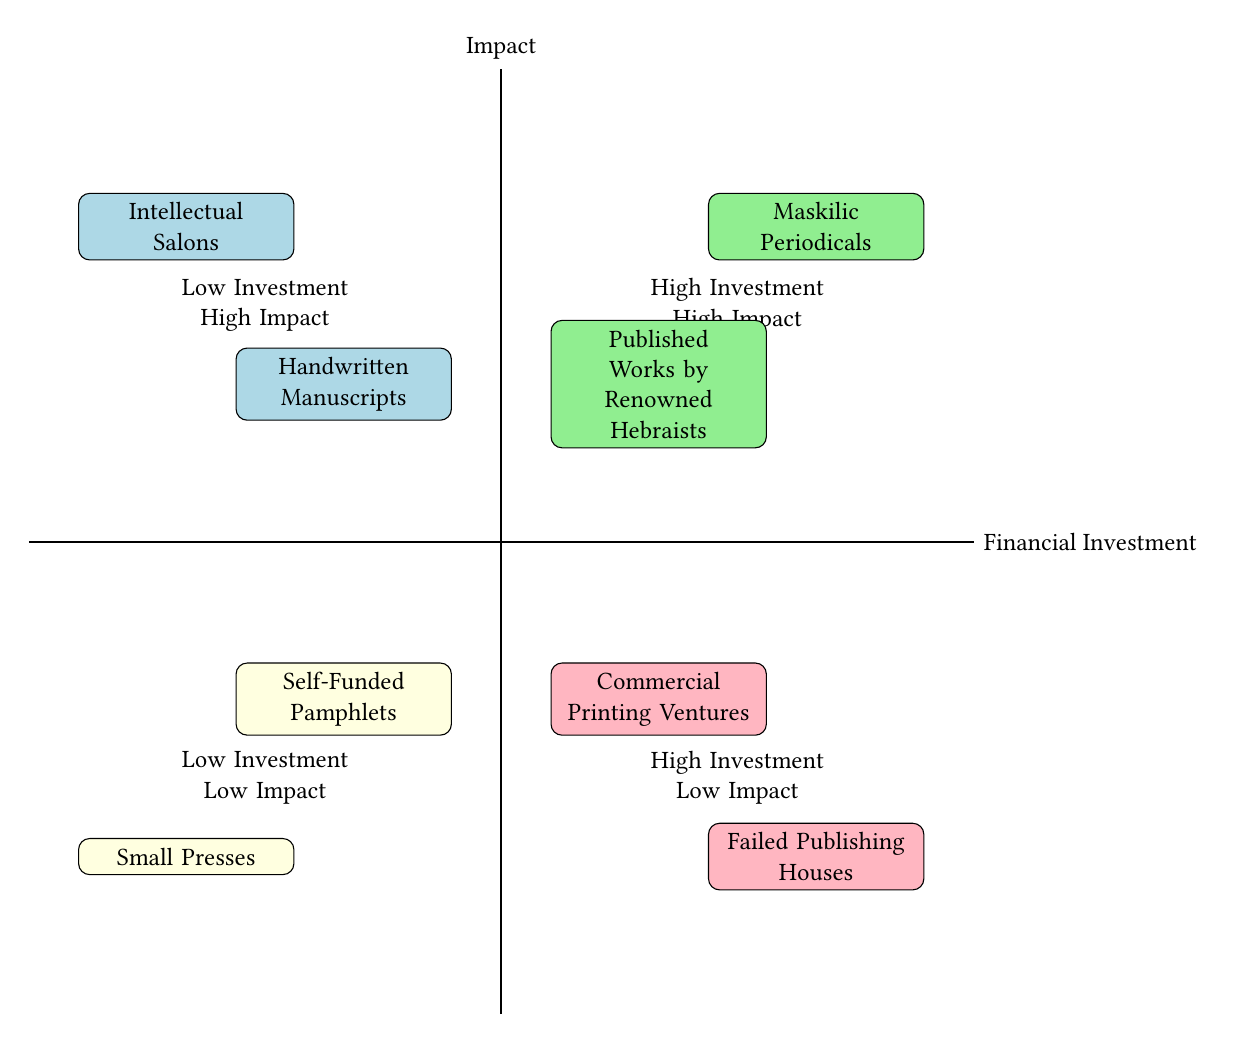What's in the Low Investment High Impact quadrant? The Low Investment High Impact quadrant contains "Intellectual Salons" and "Handwritten Manuscripts." By locating this quadrant on the chart, we can identify these two specific nodes that signify low financial investment but high cultural or literary impact.
Answer: Intellectual Salons, Handwritten Manuscripts What is a characteristic of "Maskilic Periodicals"? "Maskilic Periodicals" is highlighted in the High Investment High Impact quadrant, indicating it has significant funding while also achieving widespread distribution and lasting influence. This specific node's placement signifies its high financial investment and high impact on Hebrew literature.
Answer: Significant funding, wide distribution, lasting influence How many nodes are in the Low Financial Investment Low Impact quadrant? The Low Financial Investment Low Impact quadrant includes two nodes: "Small Presses" and "Self-Funded Pamphlets." By counting the nodes located in this quadrant, we can determine the total number present.
Answer: 2 Which quadrant has "Failed Publishing Houses"? "Failed Publishing Houses" is located in the High Investment Low Impact quadrant. By looking for this specific node on the diagram, it becomes clear where it fits in terms of financial investment and impact.
Answer: High Investment Low Impact Which two categories demonstrate high financial investment along with impactful contributions? The High Investment High Impact quadrant features "Maskilic Periodicals" and "Published Works by Renowned Hebraists." By identifying these nodes together in this quadrant, we can see they both represent high costs and significant influence in Hebrew literary works.
Answer: Maskilic Periodicals, Published Works by Renowned Hebraists What can be inferred about "Handwritten Manuscripts"? "Handwritten Manuscripts," placed in the Low Investment High Impact quadrant, suggests that despite the limited financial resources, these manuscripts have a significant cultural influence, indicating the power of quality over quantity in literary contributions. This reasoning highlights the effectiveness of low-cost literary production in making a cultural impact.
Answer: High cultural impact What distinguishes "Commercial Printing Ventures" in terms of investment and impact? "Commercial Printing Ventures" is positioned in the High Investment Low Impact quadrant, which implies that although it requires substantial financial outlay, it does not necessarily yield a corresponding high impact on Hebrew literature, reflecting the risks involved in such ventures.
Answer: High costs, varying audience reception 